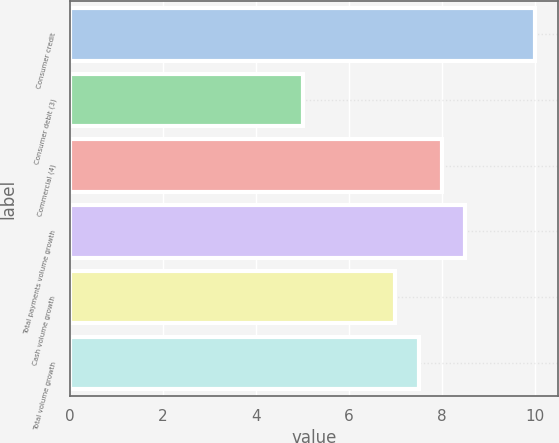Convert chart. <chart><loc_0><loc_0><loc_500><loc_500><bar_chart><fcel>Consumer credit<fcel>Consumer debit (3)<fcel>Commercial (4)<fcel>Total payments volume growth<fcel>Cash volume growth<fcel>Total volume growth<nl><fcel>10<fcel>5<fcel>8<fcel>8.5<fcel>7<fcel>7.5<nl></chart> 